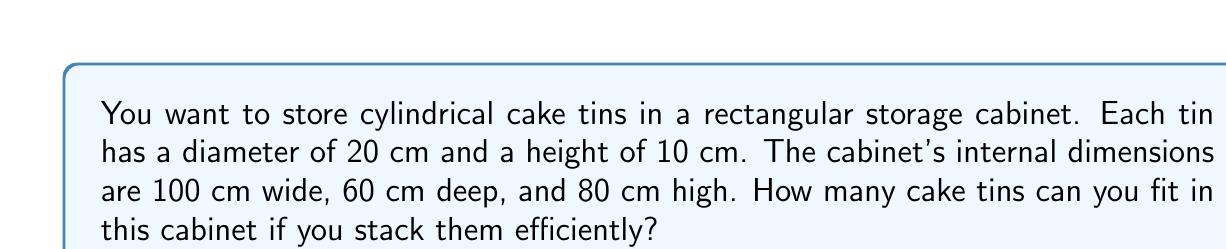Solve this math problem. Let's approach this step-by-step:

1) First, we need to calculate how many tins can fit on the cabinet floor:

   a) Area of cabinet floor: $A_{floor} = 100 \text{ cm} \times 60 \text{ cm} = 6000 \text{ cm}^2$
   
   b) Area of one tin: $A_{tin} = \pi r^2 = \pi (10 \text{ cm})^2 = 100\pi \text{ cm}^2$
   
   c) Number of tins on floor: $N_{floor} = \lfloor \frac{A_{floor}}{A_{tin}} \rfloor = \lfloor \frac{6000}{100\pi} \rfloor = 19$

2) Next, we calculate how many tins can be stacked vertically:

   a) Height of cabinet: 80 cm
   b) Height of each tin: 10 cm
   c) Number of tins in a stack: $N_{stack} = \lfloor \frac{80 \text{ cm}}{10 \text{ cm}} \rfloor = 8$

3) Total number of tins:

   $N_{total} = N_{floor} \times N_{stack} = 19 \times 8 = 152$

Therefore, you can fit 152 cake tins in the cabinet.

[asy]
size(200);
draw((0,0)--(100,0)--(100,80)--(0,80)--cycle);
draw((0,0)--(60,0));
draw((100,0)--(100,60)--(0,60));
label("100 cm", (50,-5));
label("60 cm", (105,30), E);
label("80 cm", (-5,40), W);
for(int i=0; i<5; ++i) {
  for(int j=0; j<3; ++j) {
    draw(circle((20+i*20,20+j*20),10));
  }
}
[/asy]
Answer: 152 tins 